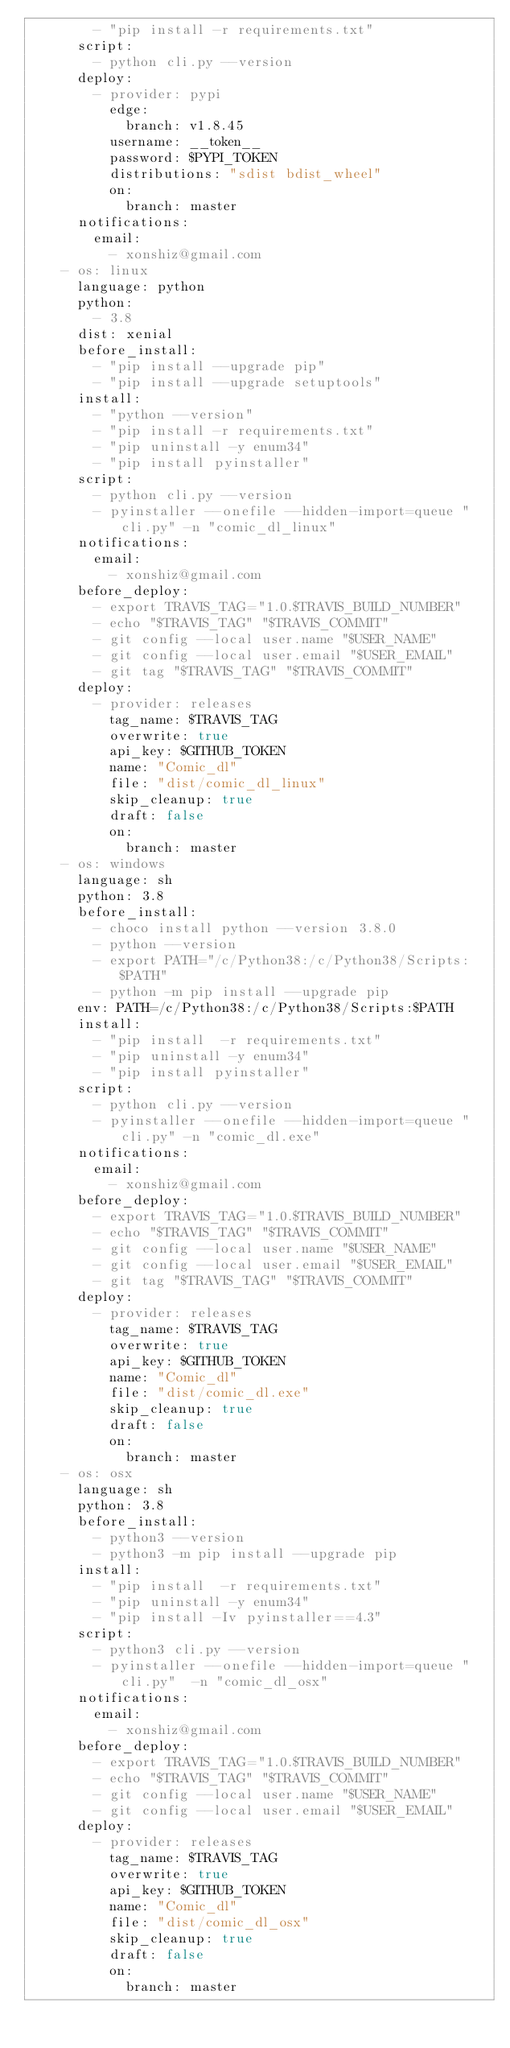<code> <loc_0><loc_0><loc_500><loc_500><_YAML_>        - "pip install -r requirements.txt"
      script:
        - python cli.py --version
      deploy:
        - provider: pypi
          edge:
            branch: v1.8.45
          username: __token__
          password: $PYPI_TOKEN
          distributions: "sdist bdist_wheel"
          on:
            branch: master
      notifications:
        email:
          - xonshiz@gmail.com
    - os: linux
      language: python
      python:
        - 3.8
      dist: xenial
      before_install:
        - "pip install --upgrade pip"
        - "pip install --upgrade setuptools"
      install:
        - "python --version"
        - "pip install -r requirements.txt"
        - "pip uninstall -y enum34"
        - "pip install pyinstaller"
      script:
        - python cli.py --version
        - pyinstaller --onefile --hidden-import=queue "cli.py" -n "comic_dl_linux"
      notifications:
        email:
          - xonshiz@gmail.com
      before_deploy:
        - export TRAVIS_TAG="1.0.$TRAVIS_BUILD_NUMBER"
        - echo "$TRAVIS_TAG" "$TRAVIS_COMMIT"
        - git config --local user.name "$USER_NAME"
        - git config --local user.email "$USER_EMAIL"
        - git tag "$TRAVIS_TAG" "$TRAVIS_COMMIT"
      deploy:
        - provider: releases
          tag_name: $TRAVIS_TAG
          overwrite: true
          api_key: $GITHUB_TOKEN
          name: "Comic_dl"
          file: "dist/comic_dl_linux"
          skip_cleanup: true
          draft: false
          on:
            branch: master
    - os: windows
      language: sh
      python: 3.8
      before_install:
        - choco install python --version 3.8.0
        - python --version
        - export PATH="/c/Python38:/c/Python38/Scripts:$PATH"
        - python -m pip install --upgrade pip
      env: PATH=/c/Python38:/c/Python38/Scripts:$PATH
      install:
        - "pip install  -r requirements.txt"
        - "pip uninstall -y enum34"
        - "pip install pyinstaller"
      script:
        - python cli.py --version
        - pyinstaller --onefile --hidden-import=queue "cli.py" -n "comic_dl.exe"
      notifications:
        email:
          - xonshiz@gmail.com
      before_deploy:
        - export TRAVIS_TAG="1.0.$TRAVIS_BUILD_NUMBER"
        - echo "$TRAVIS_TAG" "$TRAVIS_COMMIT"
        - git config --local user.name "$USER_NAME"
        - git config --local user.email "$USER_EMAIL"
        - git tag "$TRAVIS_TAG" "$TRAVIS_COMMIT"
      deploy:
        - provider: releases
          tag_name: $TRAVIS_TAG
          overwrite: true
          api_key: $GITHUB_TOKEN
          name: "Comic_dl"
          file: "dist/comic_dl.exe"
          skip_cleanup: true
          draft: false
          on:
            branch: master
    - os: osx
      language: sh
      python: 3.8
      before_install:
        - python3 --version
        - python3 -m pip install --upgrade pip
      install:
        - "pip install  -r requirements.txt"
        - "pip uninstall -y enum34"
        - "pip install -Iv pyinstaller==4.3"
      script:
        - python3 cli.py --version
        - pyinstaller --onefile --hidden-import=queue "cli.py"  -n "comic_dl_osx"
      notifications:
        email:
          - xonshiz@gmail.com
      before_deploy:
        - export TRAVIS_TAG="1.0.$TRAVIS_BUILD_NUMBER"
        - echo "$TRAVIS_TAG" "$TRAVIS_COMMIT"
        - git config --local user.name "$USER_NAME"
        - git config --local user.email "$USER_EMAIL"
      deploy:
        - provider: releases
          tag_name: $TRAVIS_TAG
          overwrite: true
          api_key: $GITHUB_TOKEN
          name: "Comic_dl"
          file: "dist/comic_dl_osx"
          skip_cleanup: true
          draft: false
          on:
            branch: master
</code> 